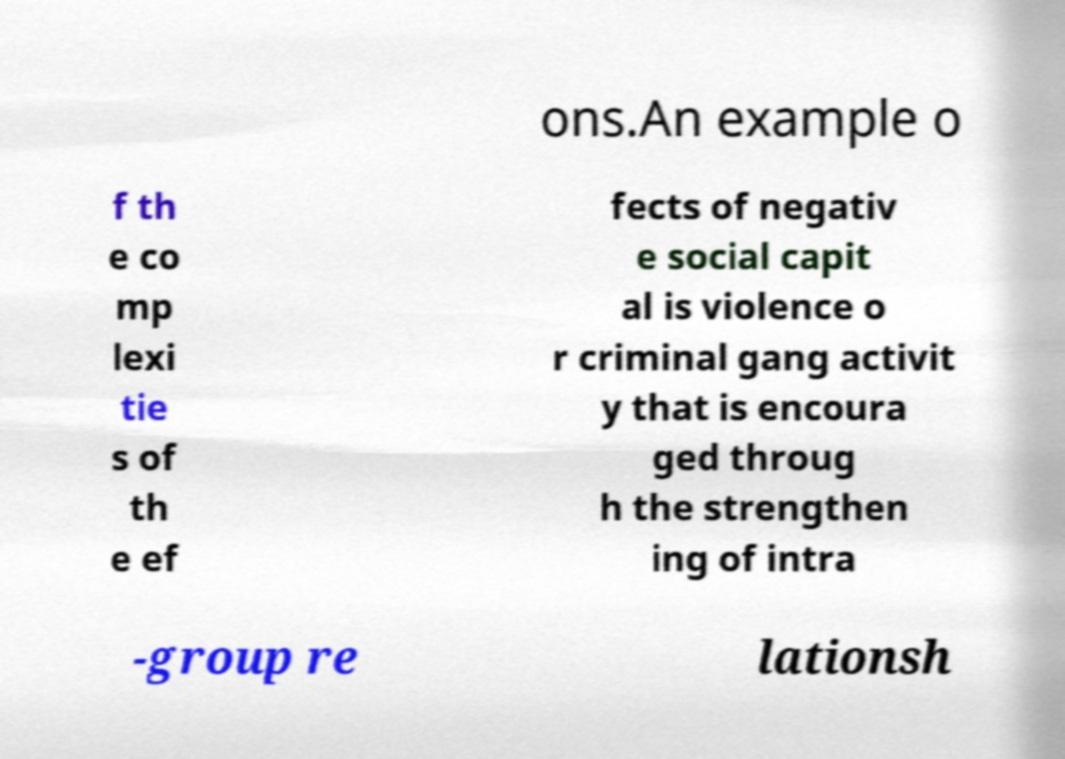Can you accurately transcribe the text from the provided image for me? ons.An example o f th e co mp lexi tie s of th e ef fects of negativ e social capit al is violence o r criminal gang activit y that is encoura ged throug h the strengthen ing of intra -group re lationsh 